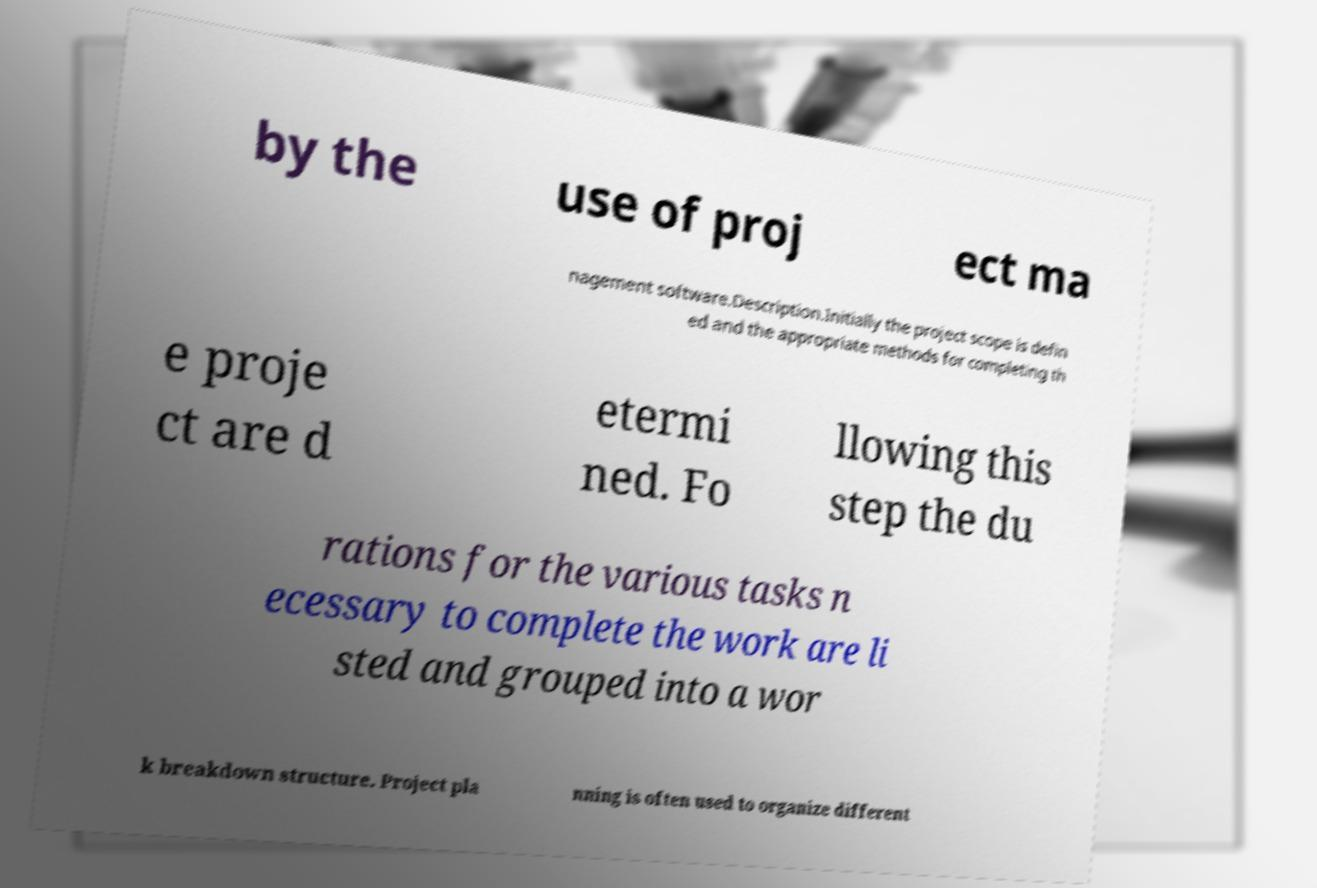What messages or text are displayed in this image? I need them in a readable, typed format. by the use of proj ect ma nagement software.Description.Initially the project scope is defin ed and the appropriate methods for completing th e proje ct are d etermi ned. Fo llowing this step the du rations for the various tasks n ecessary to complete the work are li sted and grouped into a wor k breakdown structure. Project pla nning is often used to organize different 